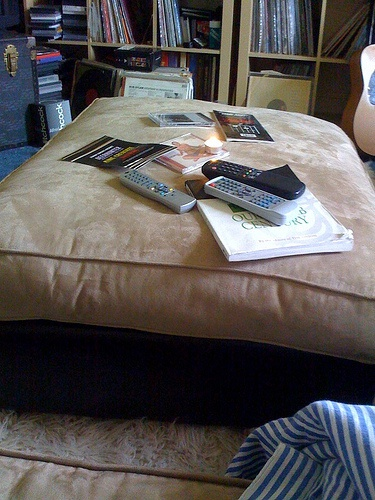Describe the objects in this image and their specific colors. I can see bed in black, darkgray, gray, and lightgray tones, book in black, white, gray, and darkgray tones, book in black, gray, and darkgray tones, book in black, gray, darkgray, and maroon tones, and remote in black, gray, and darkgray tones in this image. 